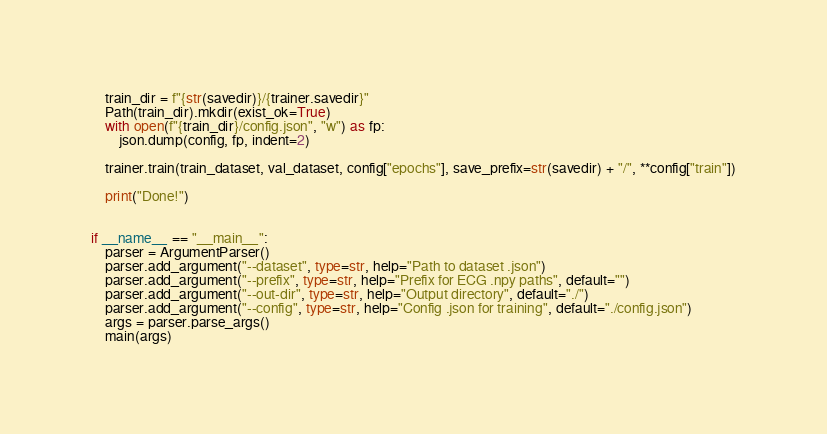<code> <loc_0><loc_0><loc_500><loc_500><_Python_>
    train_dir = f"{str(savedir)}/{trainer.savedir}"
    Path(train_dir).mkdir(exist_ok=True)
    with open(f"{train_dir}/config.json", "w") as fp:
        json.dump(config, fp, indent=2)

    trainer.train(train_dataset, val_dataset, config["epochs"], save_prefix=str(savedir) + "/", **config["train"])

    print("Done!")


if __name__ == "__main__":
    parser = ArgumentParser()
    parser.add_argument("--dataset", type=str, help="Path to dataset .json")
    parser.add_argument("--prefix", type=str, help="Prefix for ECG .npy paths", default="")
    parser.add_argument("--out-dir", type=str, help="Output directory", default="./")
    parser.add_argument("--config", type=str, help="Config .json for training", default="./config.json")
    args = parser.parse_args()
    main(args)
</code> 